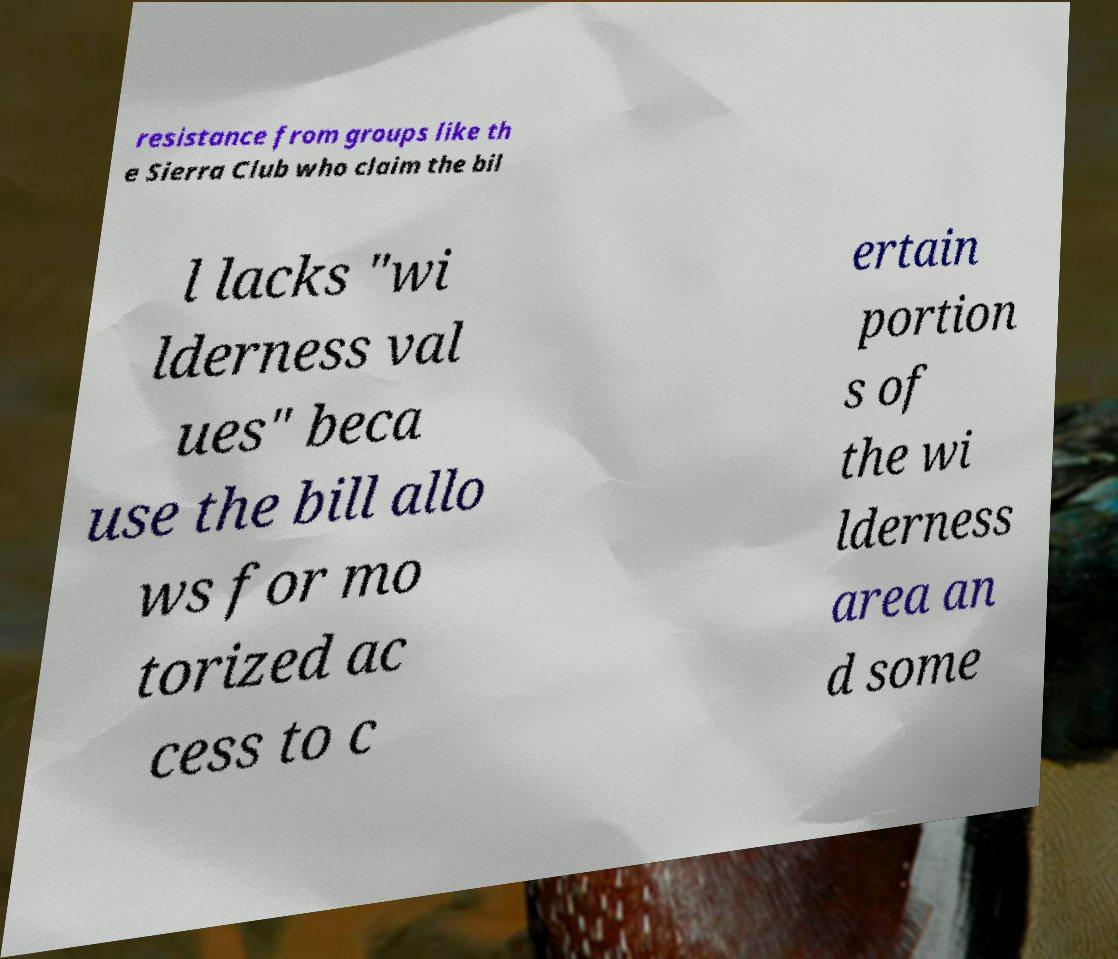Can you accurately transcribe the text from the provided image for me? resistance from groups like th e Sierra Club who claim the bil l lacks "wi lderness val ues" beca use the bill allo ws for mo torized ac cess to c ertain portion s of the wi lderness area an d some 